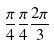<formula> <loc_0><loc_0><loc_500><loc_500>\frac { \pi } { 4 } \frac { \pi } { 4 } \frac { 2 \pi } { 3 }</formula> 